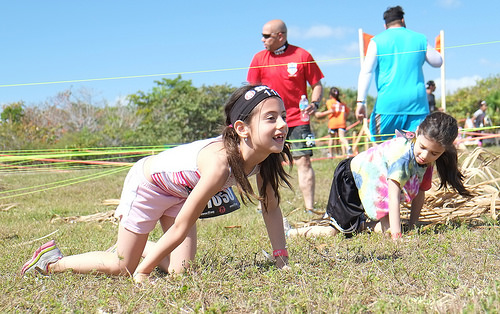<image>
Can you confirm if the tall girl is in front of the short girl? Yes. The tall girl is positioned in front of the short girl, appearing closer to the camera viewpoint. 